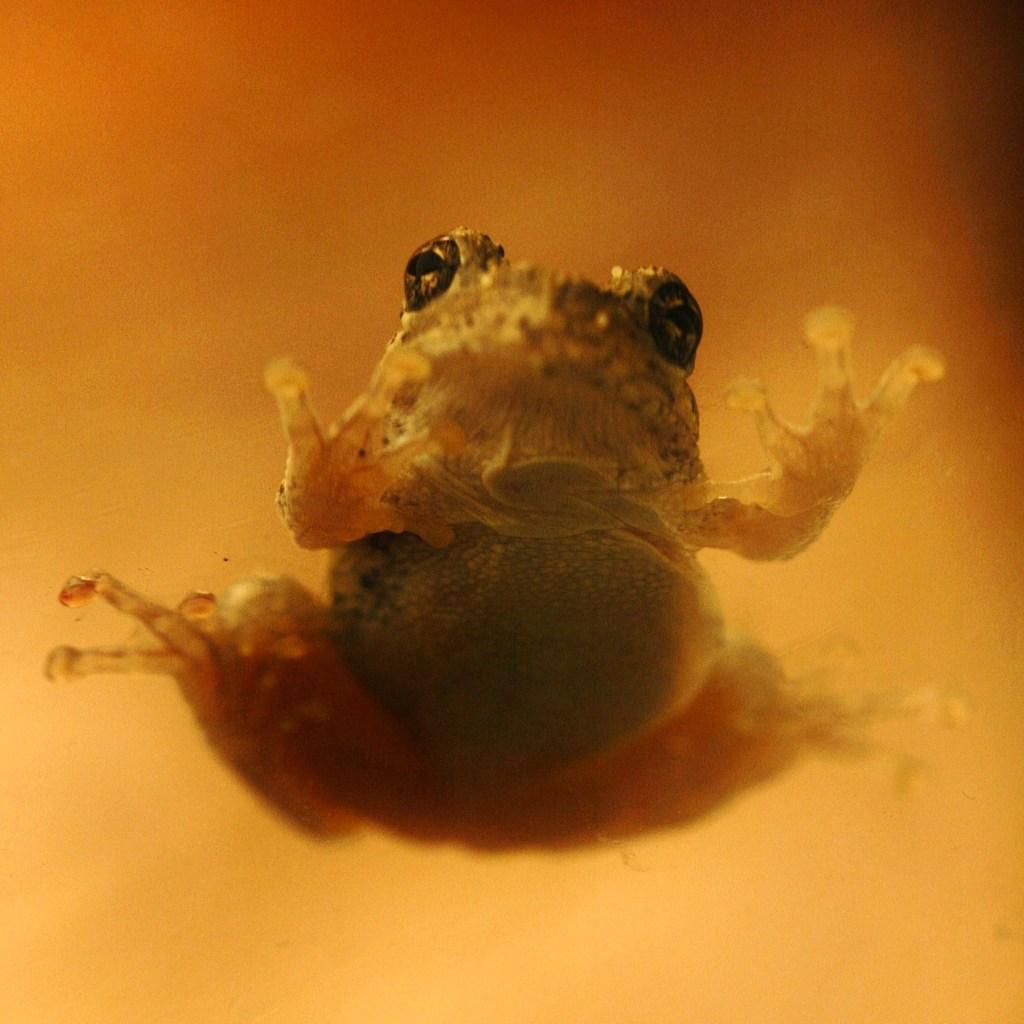What type of animal is in the image? There is a frog in the image. Where is the frog located in the image? The frog is located at the bottom side of the image. What type of rice is being served in the image? There is no rice present in the image; it features a frog located at the bottom side. 